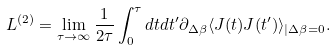Convert formula to latex. <formula><loc_0><loc_0><loc_500><loc_500>L ^ { ( 2 ) } & = \lim _ { \tau \to \infty } \frac { 1 } { 2 \tau } \int _ { 0 } ^ { \tau } d t d t ^ { \prime } \partial _ { \Delta \beta } \langle J ( t ) J ( t ^ { \prime } ) \rangle _ { | \Delta \beta = 0 } .</formula> 